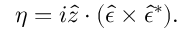Convert formula to latex. <formula><loc_0><loc_0><loc_500><loc_500>\eta = i \hat { z } \cdot ( \hat { \epsilon } \times \hat { \epsilon } ^ { \ast } ) .</formula> 